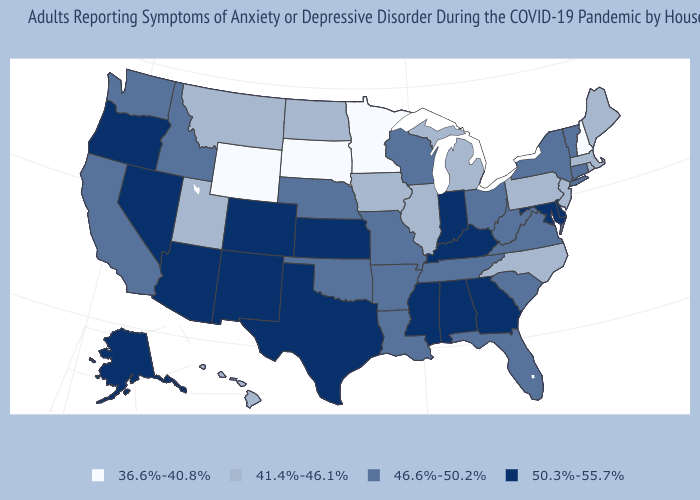Name the states that have a value in the range 41.4%-46.1%?
Be succinct. Hawaii, Illinois, Iowa, Maine, Massachusetts, Michigan, Montana, New Jersey, North Carolina, North Dakota, Pennsylvania, Rhode Island, Utah. Does Pennsylvania have a lower value than Montana?
Write a very short answer. No. Name the states that have a value in the range 41.4%-46.1%?
Be succinct. Hawaii, Illinois, Iowa, Maine, Massachusetts, Michigan, Montana, New Jersey, North Carolina, North Dakota, Pennsylvania, Rhode Island, Utah. Name the states that have a value in the range 41.4%-46.1%?
Give a very brief answer. Hawaii, Illinois, Iowa, Maine, Massachusetts, Michigan, Montana, New Jersey, North Carolina, North Dakota, Pennsylvania, Rhode Island, Utah. Is the legend a continuous bar?
Short answer required. No. What is the highest value in the USA?
Answer briefly. 50.3%-55.7%. Is the legend a continuous bar?
Write a very short answer. No. What is the value of West Virginia?
Keep it brief. 46.6%-50.2%. What is the value of Maine?
Short answer required. 41.4%-46.1%. Which states have the highest value in the USA?
Concise answer only. Alabama, Alaska, Arizona, Colorado, Delaware, Georgia, Indiana, Kansas, Kentucky, Maryland, Mississippi, Nevada, New Mexico, Oregon, Texas. Does Nebraska have the lowest value in the USA?
Keep it brief. No. Name the states that have a value in the range 41.4%-46.1%?
Answer briefly. Hawaii, Illinois, Iowa, Maine, Massachusetts, Michigan, Montana, New Jersey, North Carolina, North Dakota, Pennsylvania, Rhode Island, Utah. What is the highest value in the South ?
Answer briefly. 50.3%-55.7%. Which states have the highest value in the USA?
Answer briefly. Alabama, Alaska, Arizona, Colorado, Delaware, Georgia, Indiana, Kansas, Kentucky, Maryland, Mississippi, Nevada, New Mexico, Oregon, Texas. Among the states that border Montana , which have the lowest value?
Concise answer only. South Dakota, Wyoming. 